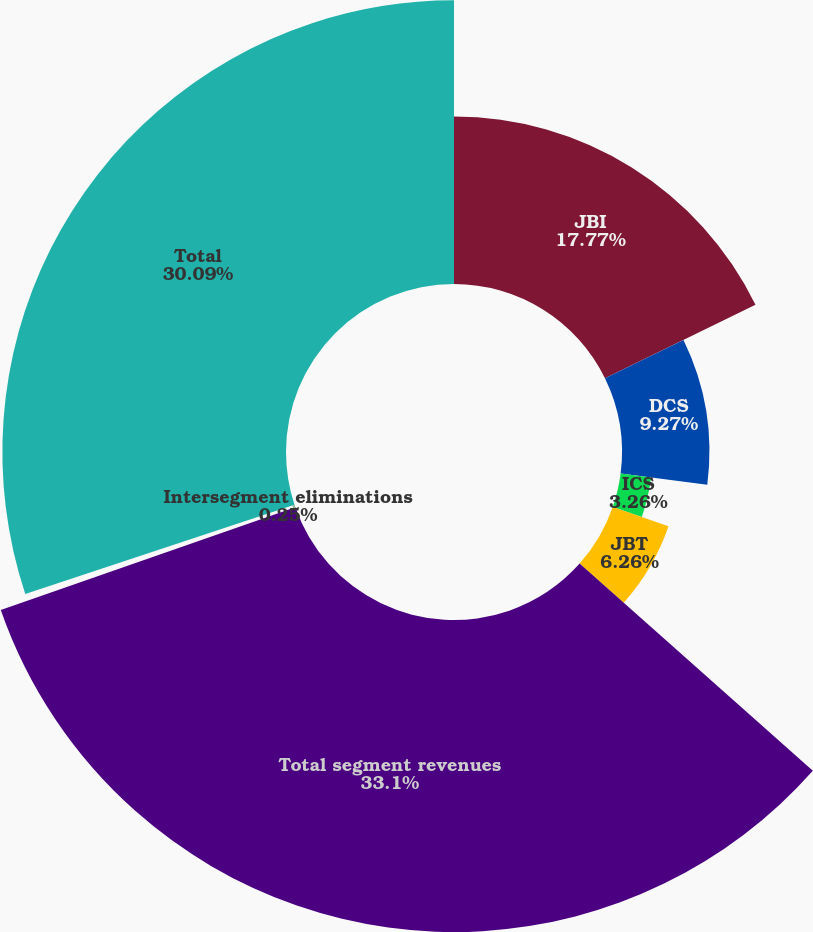Convert chart to OTSL. <chart><loc_0><loc_0><loc_500><loc_500><pie_chart><fcel>JBI<fcel>DCS<fcel>ICS<fcel>JBT<fcel>Total segment revenues<fcel>Intersegment eliminations<fcel>Total<nl><fcel>17.77%<fcel>9.27%<fcel>3.26%<fcel>6.26%<fcel>33.1%<fcel>0.25%<fcel>30.09%<nl></chart> 